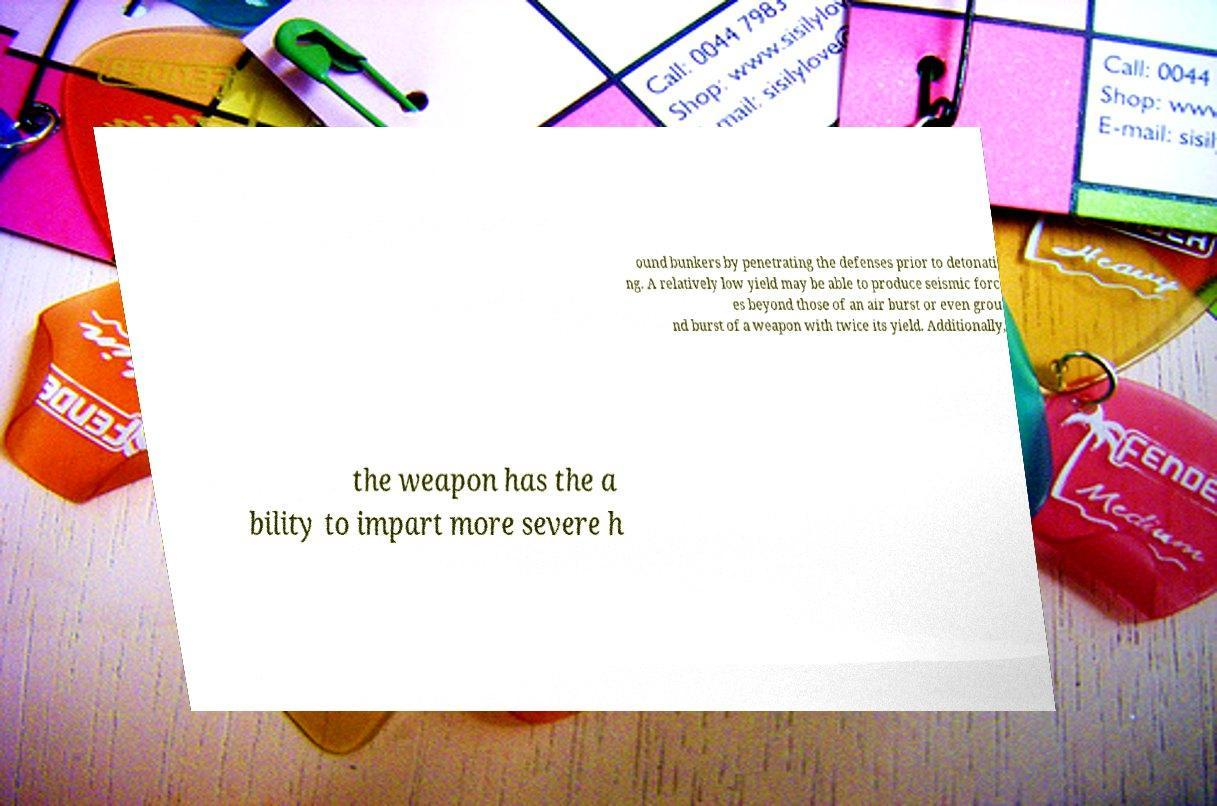Could you assist in decoding the text presented in this image and type it out clearly? ound bunkers by penetrating the defenses prior to detonati ng. A relatively low yield may be able to produce seismic forc es beyond those of an air burst or even grou nd burst of a weapon with twice its yield. Additionally, the weapon has the a bility to impart more severe h 